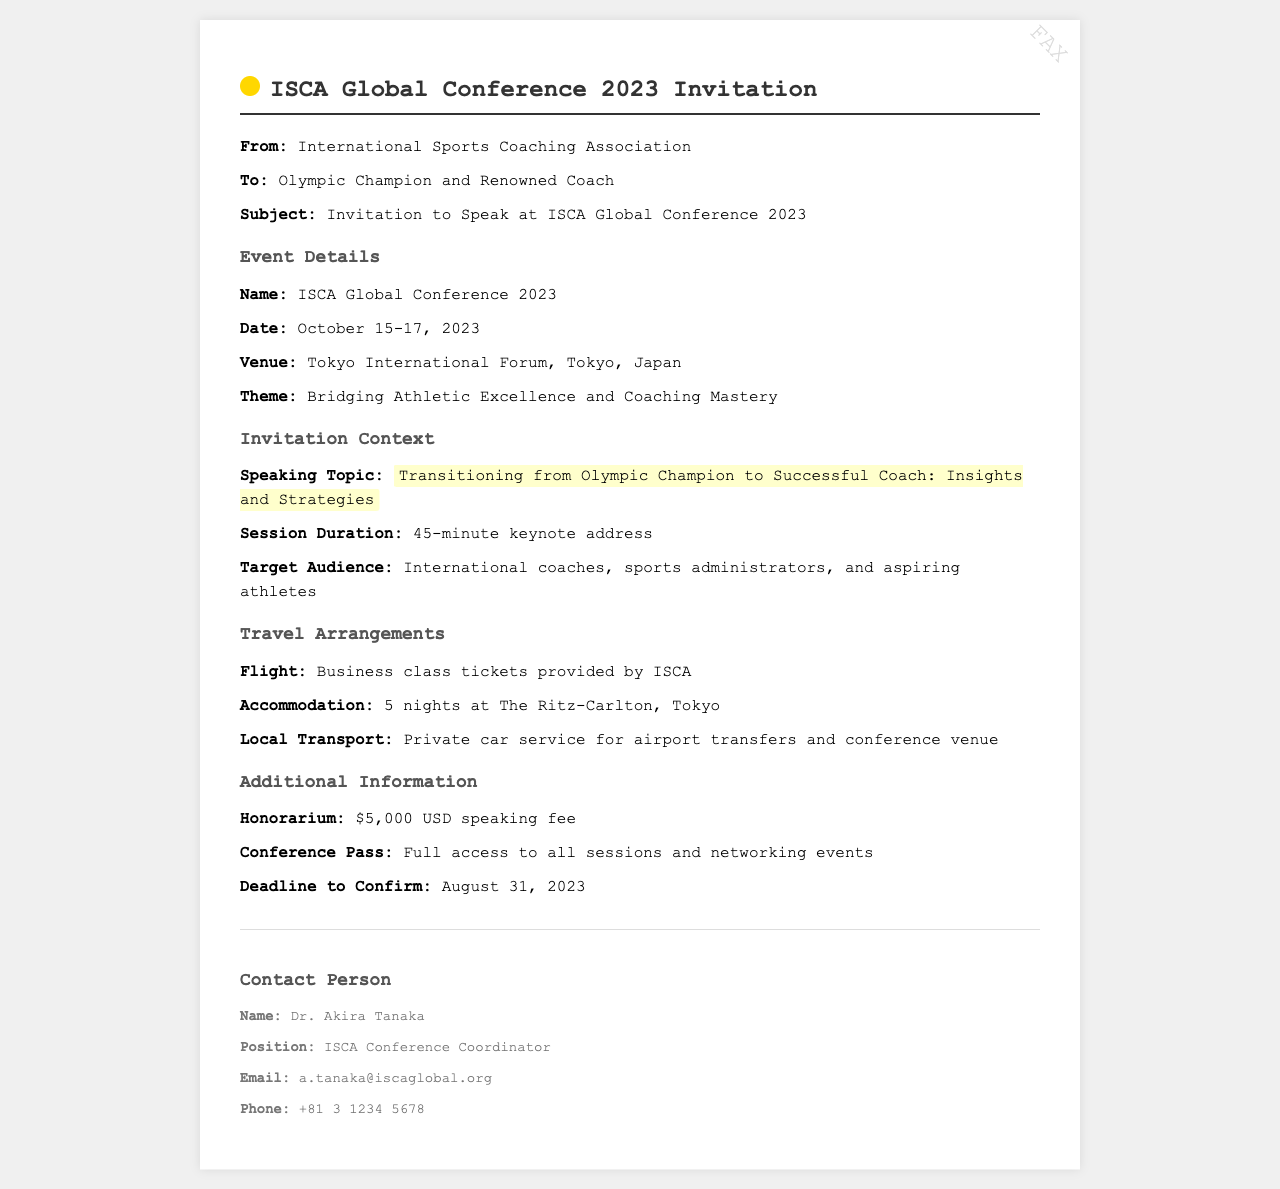what is the name of the conference? The name of the conference is stated in the document under event details.
Answer: ISCA Global Conference 2023 what are the dates of the conference? The dates are provided in the document under event details.
Answer: October 15-17, 2023 what is the speaking topic? The speaking topic is highlighted in the invitation context section of the document.
Answer: Transitioning from Olympic Champion to Successful Coach: Insights and Strategies who is the contact person for the conference? The contact person is mentioned in the footer section of the document.
Answer: Dr. Akira Tanaka what is the honorarium for speaking? The honorarium amount is listed in the additional information section of the document.
Answer: $5,000 USD what is the accommodation provided? The accommodation details are included under travel arrangements in the document.
Answer: 5 nights at The Ritz-Carlton, Tokyo what is the session duration for the keynote address? The duration for the keynote address is mentioned in the invitation context section.
Answer: 45-minute what is the deadline to confirm attendance? The deadline is specified in the additional information section of the document.
Answer: August 31, 2023 what is the theme of the conference? The theme of the conference is provided in the event details section.
Answer: Bridging Athletic Excellence and Coaching Mastery 